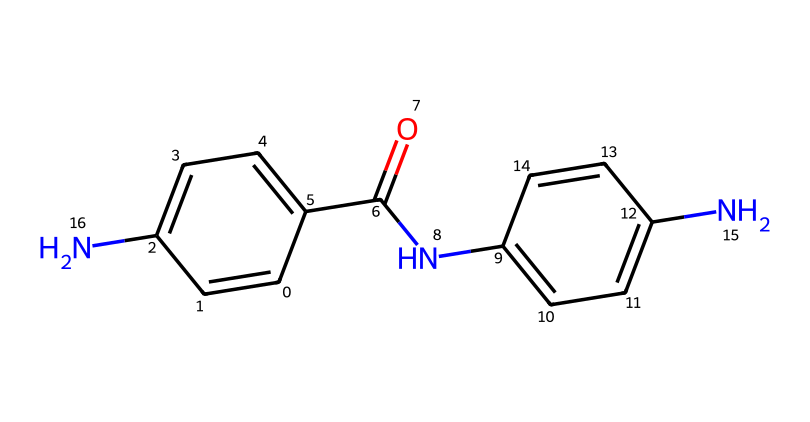What is the total number of nitrogen atoms in this structure? By examining the SMILES representation, we count the nitrogen atoms, which appear as 'N.' In the given structure, there are two nitrogen atoms present, indicated at different points in the SMILES.
Answer: 2 How many carbon atoms are present in the chemical structure? The SMILES representation contains instances of 'C,' which represent carbon atoms. Counting these within the structure reveals that there are 15 carbon atoms overall.
Answer: 15 What type of chemical is represented by this structure? The presence of multiple aromatic rings and a characteristic amide functional group (as seen from the carbonyl connected to a nitrogen) suggests that this chemical is a polymer often used in high-strength materials like Kevlar.
Answer: polymer Which functional group is present in this chemical structure? The analysis of the structure reveals an amide functional group (R-CO-NR2), which is indicated by the carbonyl (C=O) directly bonded to a nitrogen atom (N). This group is indicative of polymers like Kevlar.
Answer: amide What is the main application of the polymer represented by this chemical structure? The strong, durable characteristics of this polymer, particularly its resistance to stretching and impact, allow it to be used in protective gear, most notably in bulletproof vests for law enforcement.
Answer: bulletproof vests 